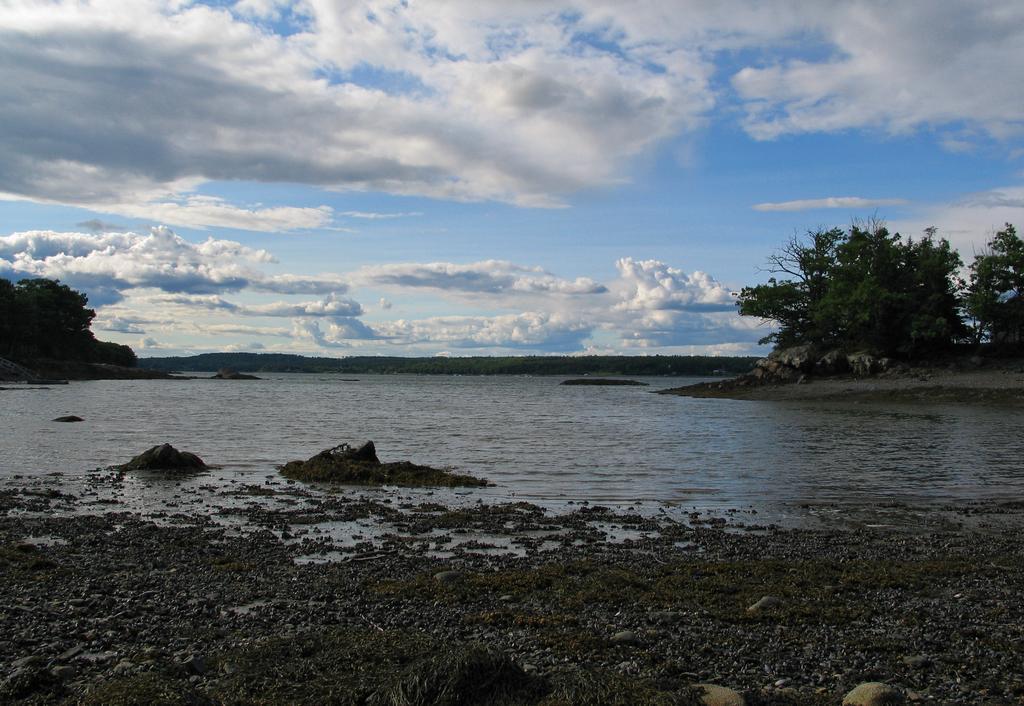How would you summarize this image in a sentence or two? In this image there is the sky truncated towards the top of the image, there are clouds in the sky, there are trees truncated towards the right of the image, there are trees truncated towards the left of the image, there is water truncated, there is soil truncated towards the bottom of the image, there are stones truncated towards the bottom of the image. 